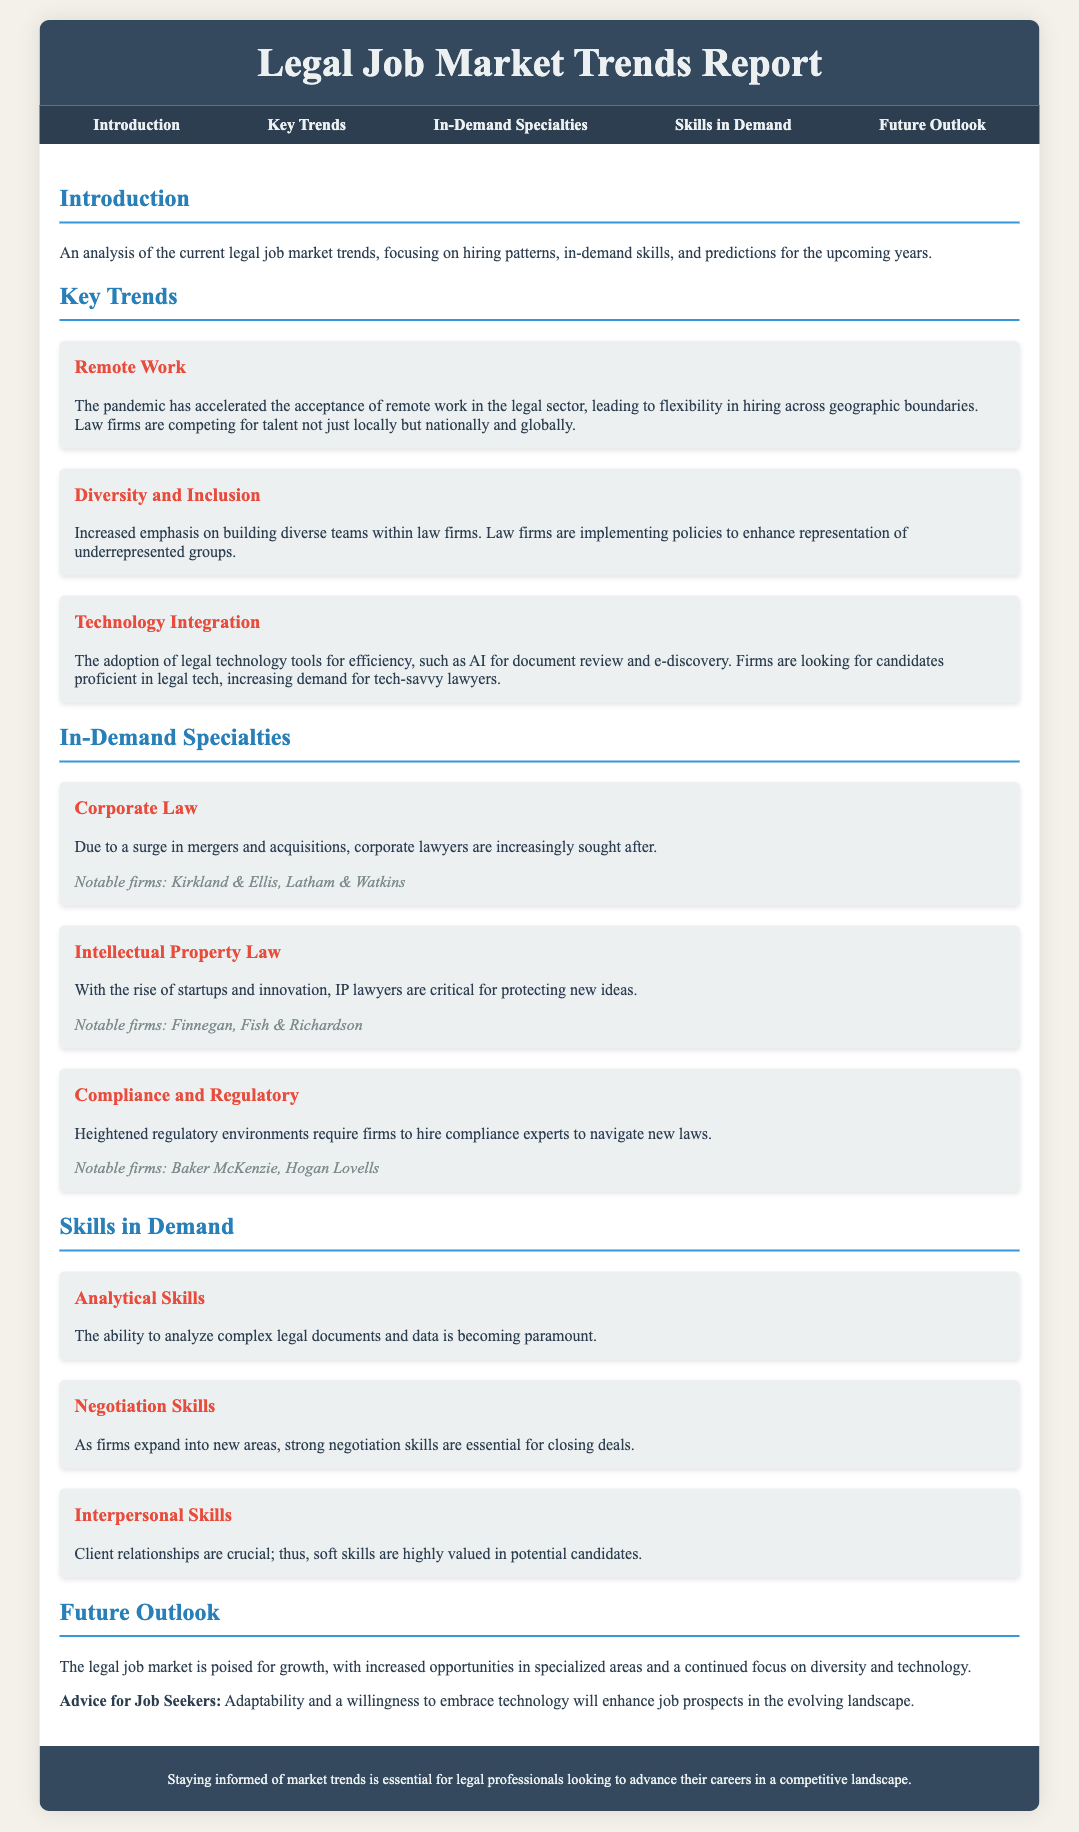What is the focus of the report? The report provides an analysis of the current legal job market trends, including hiring patterns and in-demand skills.
Answer: legal job market trends What specialty is increasingly sought after due to a surge in mergers and acquisitions? Corporate lawyers are increasingly sought after due to a surge in mergers and acquisitions.
Answer: Corporate Law What has accelerated the acceptance of remote work in the legal sector? The pandemic has accelerated the acceptance of remote work, leading to flexibility in hiring.
Answer: pandemic Which skill is described as paramount for analyzing complex legal documents? Analytical skills are becoming paramount for analyzing complex legal documents and data.
Answer: Analytical Skills What notable firm is associated with Intellectual Property Law? Finnegan is a notable firm associated with Intellectual Property Law.
Answer: Finnegan What is essential for closing deals as firms expand into new areas? Strong negotiation skills are essential for closing deals.
Answer: negotiation skills What is a key focus for law firms regarding team structure? There is an increased emphasis on building diverse teams within law firms.
Answer: Diversity and Inclusion What does the report suggest will enhance job prospects for candidates? Adaptability and a willingness to embrace technology will enhance job prospects.
Answer: Adaptability and technology What is the general outlook for the legal job market? The legal job market is poised for growth with increased opportunities.
Answer: growth 